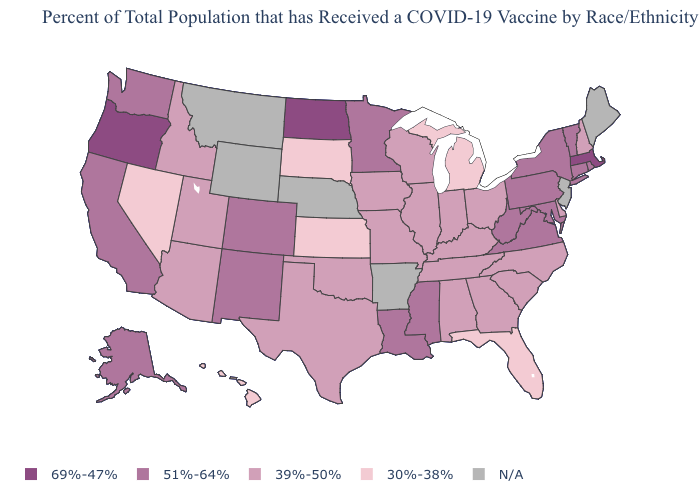What is the lowest value in the Northeast?
Concise answer only. 39%-50%. How many symbols are there in the legend?
Concise answer only. 5. Does Oregon have the highest value in the USA?
Short answer required. Yes. What is the value of Delaware?
Give a very brief answer. 39%-50%. Which states have the lowest value in the USA?
Quick response, please. Florida, Hawaii, Kansas, Michigan, Nevada, South Dakota. Does the first symbol in the legend represent the smallest category?
Concise answer only. No. Does the map have missing data?
Keep it brief. Yes. Does the map have missing data?
Keep it brief. Yes. What is the value of Michigan?
Concise answer only. 30%-38%. What is the highest value in states that border New Hampshire?
Concise answer only. 69%-47%. What is the value of Missouri?
Quick response, please. 39%-50%. Which states have the lowest value in the Northeast?
Keep it brief. New Hampshire. Name the states that have a value in the range 51%-64%?
Keep it brief. Alaska, California, Colorado, Connecticut, Louisiana, Maryland, Minnesota, Mississippi, New Mexico, New York, Pennsylvania, Rhode Island, Vermont, Virginia, Washington, West Virginia. Name the states that have a value in the range 30%-38%?
Concise answer only. Florida, Hawaii, Kansas, Michigan, Nevada, South Dakota. What is the value of Kansas?
Give a very brief answer. 30%-38%. 